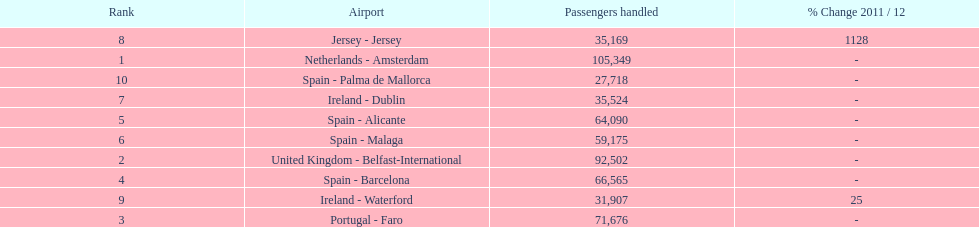Which airport has no more than 30,000 passengers handled among the 10 busiest routes to and from london southend airport in 2012? Spain - Palma de Mallorca. 